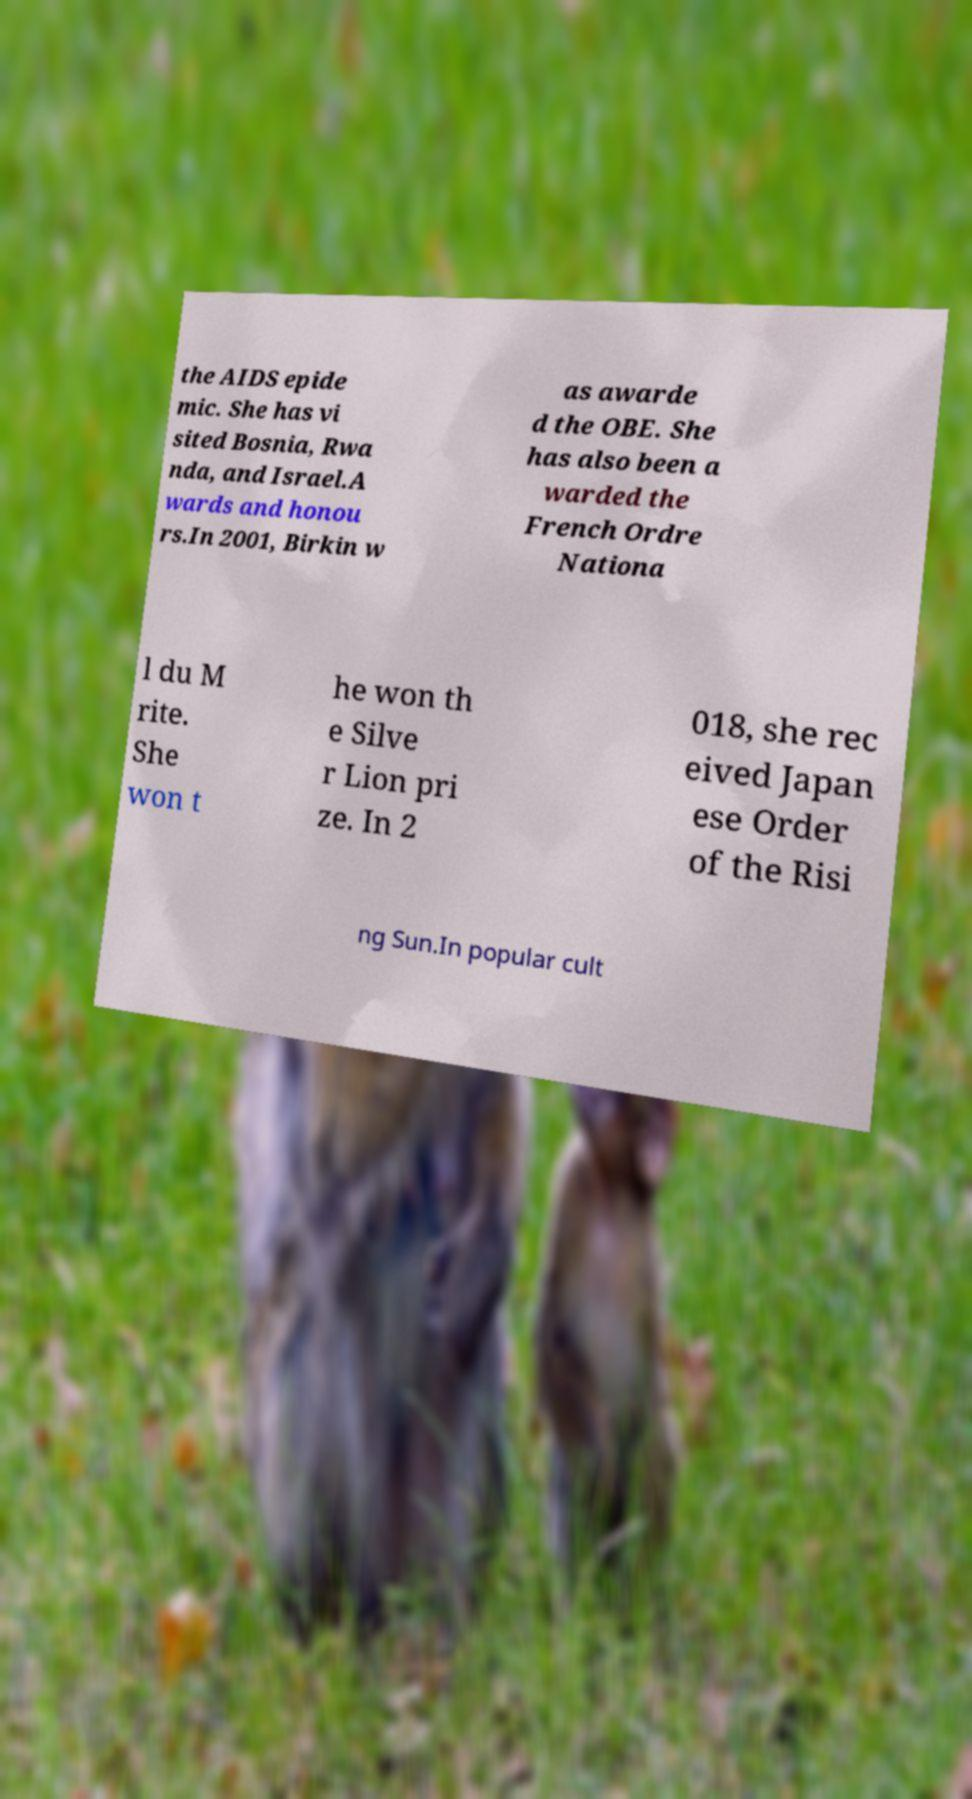What messages or text are displayed in this image? I need them in a readable, typed format. the AIDS epide mic. She has vi sited Bosnia, Rwa nda, and Israel.A wards and honou rs.In 2001, Birkin w as awarde d the OBE. She has also been a warded the French Ordre Nationa l du M rite. She won t he won th e Silve r Lion pri ze. In 2 018, she rec eived Japan ese Order of the Risi ng Sun.In popular cult 